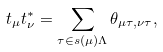<formula> <loc_0><loc_0><loc_500><loc_500>t _ { \mu } t _ { \nu } ^ { * } = \sum _ { \tau \in s ( \mu ) \Lambda } \theta _ { \mu \tau , \nu \tau } ,</formula> 